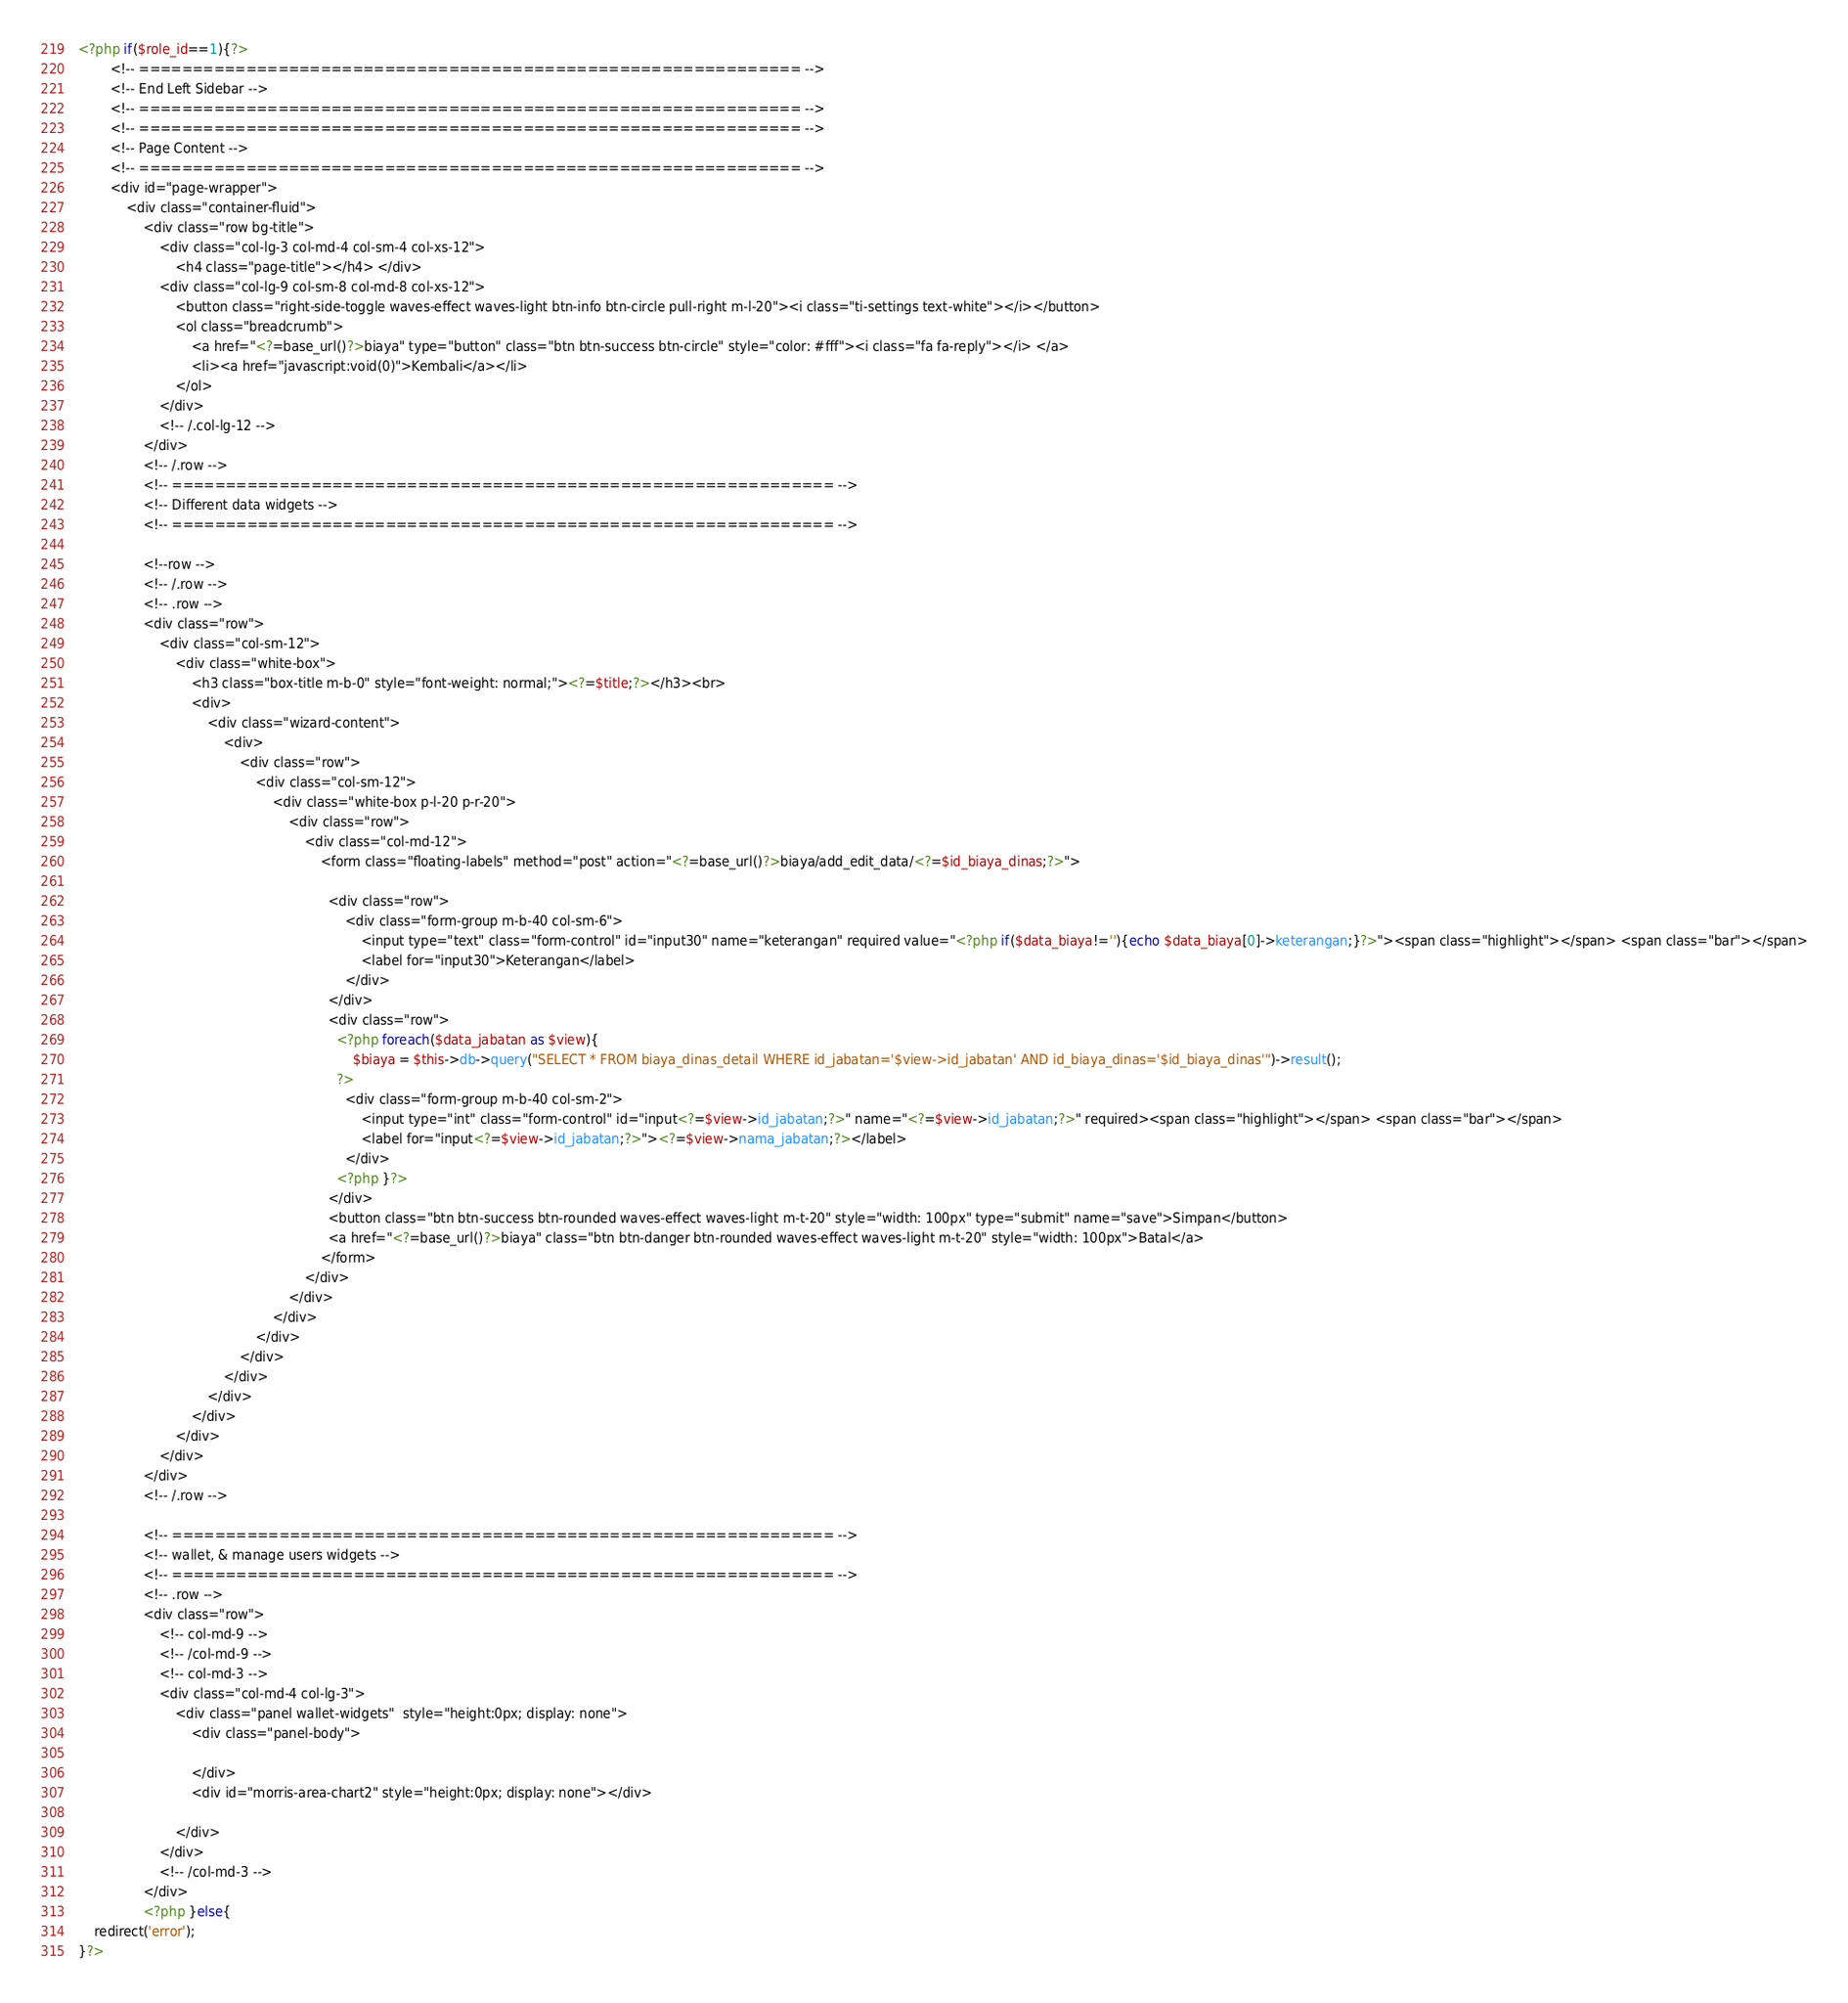Convert code to text. <code><loc_0><loc_0><loc_500><loc_500><_PHP_><?php if($role_id==1){?>
        <!-- ============================================================== -->
        <!-- End Left Sidebar -->
        <!-- ============================================================== -->
        <!-- ============================================================== -->
        <!-- Page Content -->
        <!-- ============================================================== -->
        <div id="page-wrapper">
            <div class="container-fluid">
                <div class="row bg-title">
                    <div class="col-lg-3 col-md-4 col-sm-4 col-xs-12">
                        <h4 class="page-title"></h4> </div>
                    <div class="col-lg-9 col-sm-8 col-md-8 col-xs-12">
                        <button class="right-side-toggle waves-effect waves-light btn-info btn-circle pull-right m-l-20"><i class="ti-settings text-white"></i></button>
                        <ol class="breadcrumb">
                            <a href="<?=base_url()?>biaya" type="button" class="btn btn-success btn-circle" style="color: #fff"><i class="fa fa-reply"></i> </a>
                            <li><a href="javascript:void(0)">Kembali</a></li>
                        </ol>
                    </div>
                    <!-- /.col-lg-12 -->
                </div>
                <!-- /.row -->
                <!-- ============================================================== -->
                <!-- Different data widgets -->
                <!-- ============================================================== -->
                
                <!--row -->
                <!-- /.row -->
                <!-- .row -->
                <div class="row">
                    <div class="col-sm-12">
                        <div class="white-box">
                            <h3 class="box-title m-b-0" style="font-weight: normal;"><?=$title;?></h3><br>
                            <div>
                                <div class="wizard-content">
                                    <div>
                                        <div class="row">
                                            <div class="col-sm-12">
                                                <div class="white-box p-l-20 p-r-20">
                                                    <div class="row">
                                                        <div class="col-md-12">
                                                            <form class="floating-labels" method="post" action="<?=base_url()?>biaya/add_edit_data/<?=$id_biaya_dinas;?>">
                                                            
                                                              <div class="row">
                                                                  <div class="form-group m-b-40 col-sm-6">
                                                                      <input type="text" class="form-control" id="input30" name="keterangan" required value="<?php if($data_biaya!=''){echo $data_biaya[0]->keterangan;}?>"><span class="highlight"></span> <span class="bar"></span>
                                                                      <label for="input30">Keterangan</label>
                                                                  </div>
                                                              </div>
                                                              <div class="row">
                                                                <?php foreach($data_jabatan as $view){
                                                                    $biaya = $this->db->query("SELECT * FROM biaya_dinas_detail WHERE id_jabatan='$view->id_jabatan' AND id_biaya_dinas='$id_biaya_dinas'")->result();
                                                                ?>
                                                                  <div class="form-group m-b-40 col-sm-2">
                                                                      <input type="int" class="form-control" id="input<?=$view->id_jabatan;?>" name="<?=$view->id_jabatan;?>" required><span class="highlight"></span> <span class="bar"></span>
                                                                      <label for="input<?=$view->id_jabatan;?>"><?=$view->nama_jabatan;?></label>
                                                                  </div>
                                                                <?php }?>
                                                              </div>
                                                              <button class="btn btn-success btn-rounded waves-effect waves-light m-t-20" style="width: 100px" type="submit" name="save">Simpan</button>
                                                              <a href="<?=base_url()?>biaya" class="btn btn-danger btn-rounded waves-effect waves-light m-t-20" style="width: 100px">Batal</a>
                                                            </form>
                                                        </div>
                                                    </div>
                                                </div>
                                            </div>
                                        </div>
                                    </div>
                                </div>
                            </div>
                        </div>
                    </div>
                </div>
                <!-- /.row -->
                
                <!-- ============================================================== -->
                <!-- wallet, & manage users widgets -->
                <!-- ============================================================== -->
                <!-- .row -->
                <div class="row">
                    <!-- col-md-9 -->
                    <!-- /col-md-9 -->
                    <!-- col-md-3 -->
                    <div class="col-md-4 col-lg-3">
                        <div class="panel wallet-widgets"  style="height:0px; display: none">
                            <div class="panel-body">
                                
                            </div>
                            <div id="morris-area-chart2" style="height:0px; display: none"></div>
                            
                        </div>
                    </div>
                    <!-- /col-md-3 -->
                </div>
                <?php }else{
    redirect('error');
}?></code> 